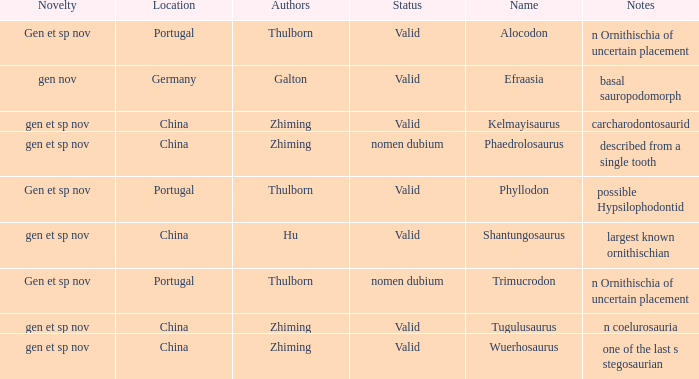Give me the full table as a dictionary. {'header': ['Novelty', 'Location', 'Authors', 'Status', 'Name', 'Notes'], 'rows': [['Gen et sp nov', 'Portugal', 'Thulborn', 'Valid', 'Alocodon', 'n Ornithischia of uncertain placement'], ['gen nov', 'Germany', 'Galton', 'Valid', 'Efraasia', 'basal sauropodomorph'], ['gen et sp nov', 'China', 'Zhiming', 'Valid', 'Kelmayisaurus', 'carcharodontosaurid'], ['gen et sp nov', 'China', 'Zhiming', 'nomen dubium', 'Phaedrolosaurus', 'described from a single tooth'], ['Gen et sp nov', 'Portugal', 'Thulborn', 'Valid', 'Phyllodon', 'possible Hypsilophodontid'], ['gen et sp nov', 'China', 'Hu', 'Valid', 'Shantungosaurus', 'largest known ornithischian'], ['Gen et sp nov', 'Portugal', 'Thulborn', 'nomen dubium', 'Trimucrodon', 'n Ornithischia of uncertain placement'], ['gen et sp nov', 'China', 'Zhiming', 'Valid', 'Tugulusaurus', 'n coelurosauria'], ['gen et sp nov', 'China', 'Zhiming', 'Valid', 'Wuerhosaurus', 'one of the last s stegosaurian']]} What is the Status of the dinosaur, whose notes are, "n coelurosauria"? Valid. 